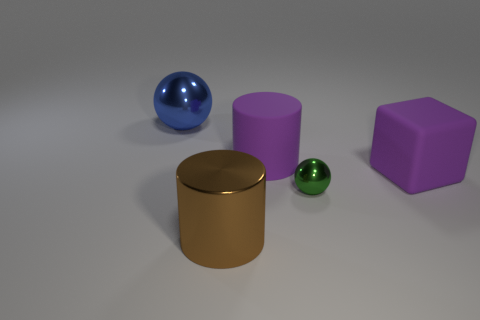Add 5 big purple matte cubes. How many objects exist? 10 Subtract all cylinders. How many objects are left? 3 Subtract all tiny brown rubber cubes. Subtract all tiny metal balls. How many objects are left? 4 Add 5 metallic things. How many metallic things are left? 8 Add 2 brown shiny cylinders. How many brown shiny cylinders exist? 3 Subtract 1 brown cylinders. How many objects are left? 4 